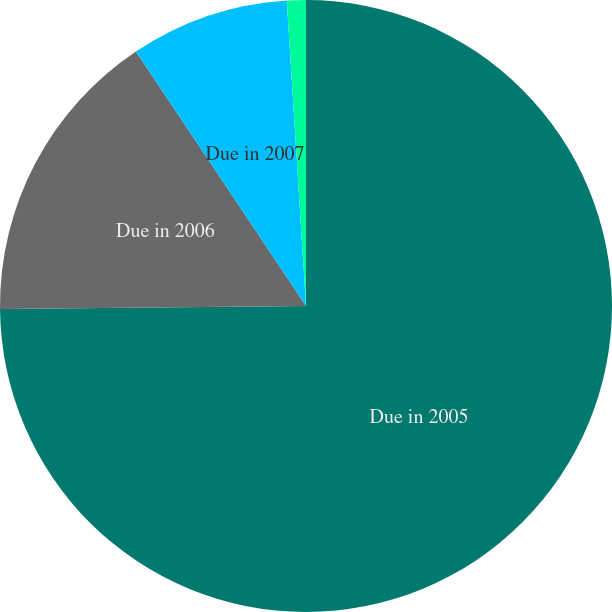Convert chart to OTSL. <chart><loc_0><loc_0><loc_500><loc_500><pie_chart><fcel>Due in 2005<fcel>Due in 2006<fcel>Due in 2007<fcel>Due in 2008<nl><fcel>74.85%<fcel>15.77%<fcel>8.38%<fcel>1.0%<nl></chart> 